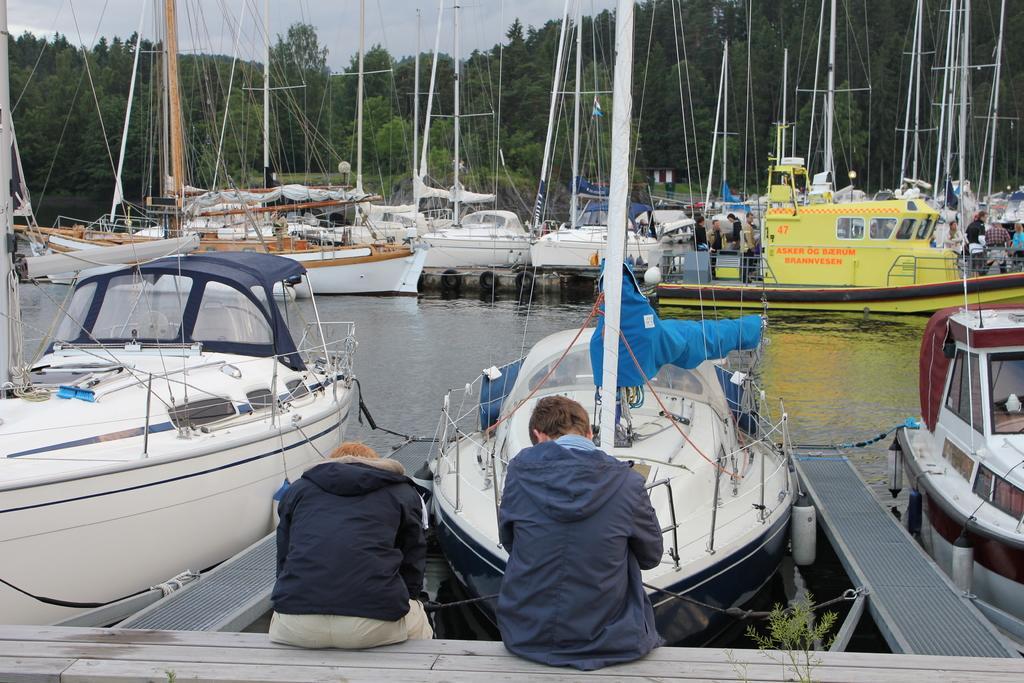Could you give a brief overview of what you see in this image? This picture is clicked outside the city. In the foreground we can see the two persons sitting on the wooden object. In the center we can see the boats in the water body and we can see the group of persons in the boats. In the background we can see the sky, trees and we can see the metal rods, ropes and some other objects. 